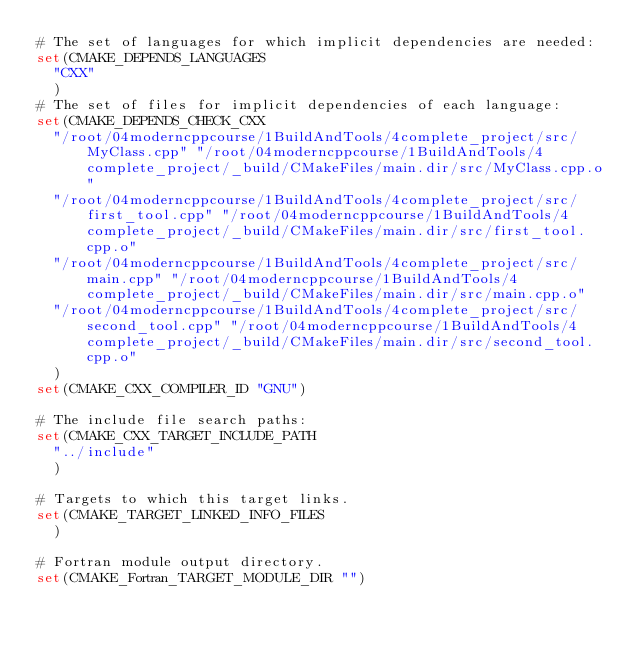<code> <loc_0><loc_0><loc_500><loc_500><_CMake_># The set of languages for which implicit dependencies are needed:
set(CMAKE_DEPENDS_LANGUAGES
  "CXX"
  )
# The set of files for implicit dependencies of each language:
set(CMAKE_DEPENDS_CHECK_CXX
  "/root/04moderncppcourse/1BuildAndTools/4complete_project/src/MyClass.cpp" "/root/04moderncppcourse/1BuildAndTools/4complete_project/_build/CMakeFiles/main.dir/src/MyClass.cpp.o"
  "/root/04moderncppcourse/1BuildAndTools/4complete_project/src/first_tool.cpp" "/root/04moderncppcourse/1BuildAndTools/4complete_project/_build/CMakeFiles/main.dir/src/first_tool.cpp.o"
  "/root/04moderncppcourse/1BuildAndTools/4complete_project/src/main.cpp" "/root/04moderncppcourse/1BuildAndTools/4complete_project/_build/CMakeFiles/main.dir/src/main.cpp.o"
  "/root/04moderncppcourse/1BuildAndTools/4complete_project/src/second_tool.cpp" "/root/04moderncppcourse/1BuildAndTools/4complete_project/_build/CMakeFiles/main.dir/src/second_tool.cpp.o"
  )
set(CMAKE_CXX_COMPILER_ID "GNU")

# The include file search paths:
set(CMAKE_CXX_TARGET_INCLUDE_PATH
  "../include"
  )

# Targets to which this target links.
set(CMAKE_TARGET_LINKED_INFO_FILES
  )

# Fortran module output directory.
set(CMAKE_Fortran_TARGET_MODULE_DIR "")
</code> 